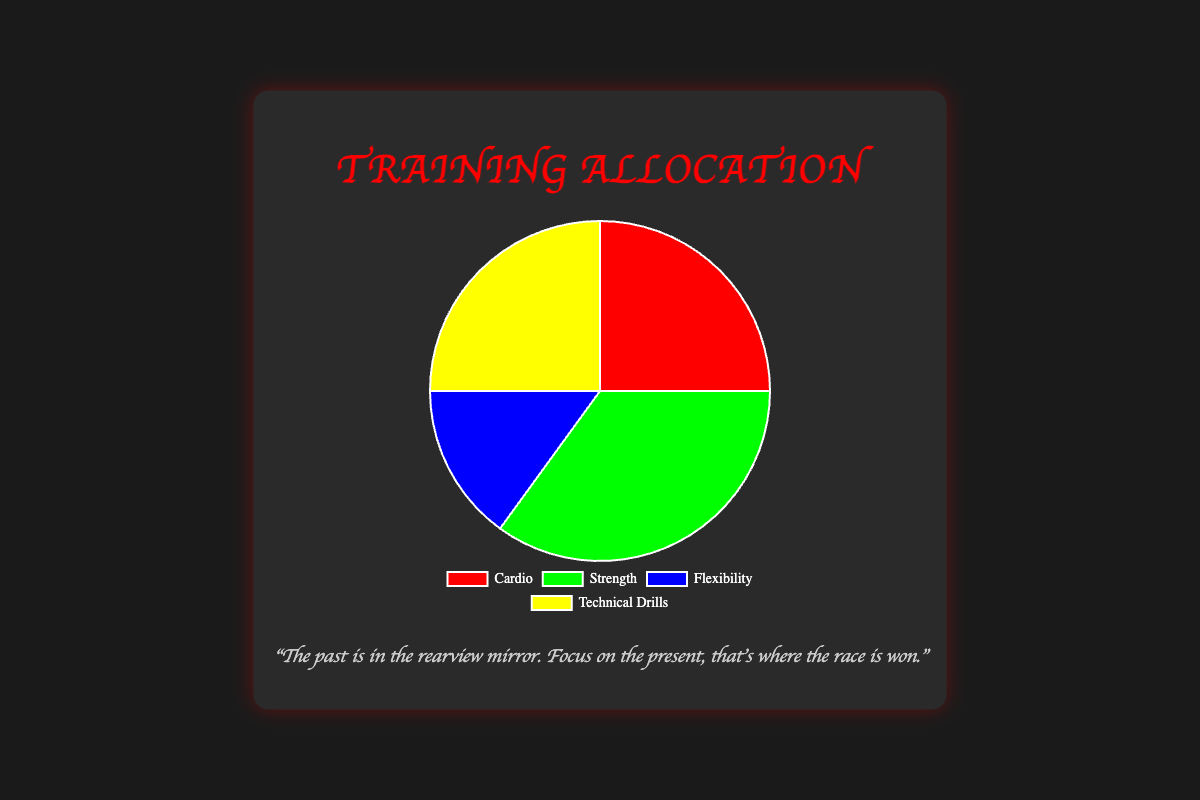Which type of training takes up the most time? Strength training takes the most time based on the figure. Comparing the percentages, Strength is at 35%, while others are lower.
Answer: Strength How much more time is allocated to Cardio compared to Flexibility? Cardio is 25% and Flexibility is 15%. The difference is calculated as 25% - 15%.
Answer: 10% Which two types of training have equal allocations? By observing the percentages, Cardio and Technical Drills both have an allocation of 25%.
Answer: Cardio and Technical Drills Which training type has the smallest allocation? Flexibility has the smallest allocation with 15%, lower than the other types.
Answer: Flexibility If 100 hours are spent training each week, how many hours are dedicated to Technical Drills? If Technical Drills constitute 25%, then 25% of 100 hours is calculated as (25/100) * 100 hours.
Answer: 25 hours Is more time spent on Strength training or the combined time of Cardio and Flexibility? Strength training is 35%. Combined time for Cardio (25%) and Flexibility (15%) is 25% + 15% = 40%, which is greater.
Answer: Combined Cardio and Flexibility Which training type is represented by a green section in the pie chart? The green section refers to Strength training, as per the visual attribute of the color green used in the chart.
Answer: Strength What percentage of time is allocated to non-technical drills training? Non-technical drills include Cardio, Strength, and Flexibility. Their combined percentage is 25% + 35% + 15% = 75%.
Answer: 75% What is the average percentage of time allocated to Cardio and Technical Drills? Both Cardio and Technical Drills have 25% each. The average is calculated by (25% + 25%) / 2.
Answer: 25% How much more time is allocated to Strength than Flexibility and Technical Drills combined? Strength has 35%. Flexibility (15%) and Technical Drills (25%) combined are 40%. The difference is 40% - 35%.
Answer: 5% 